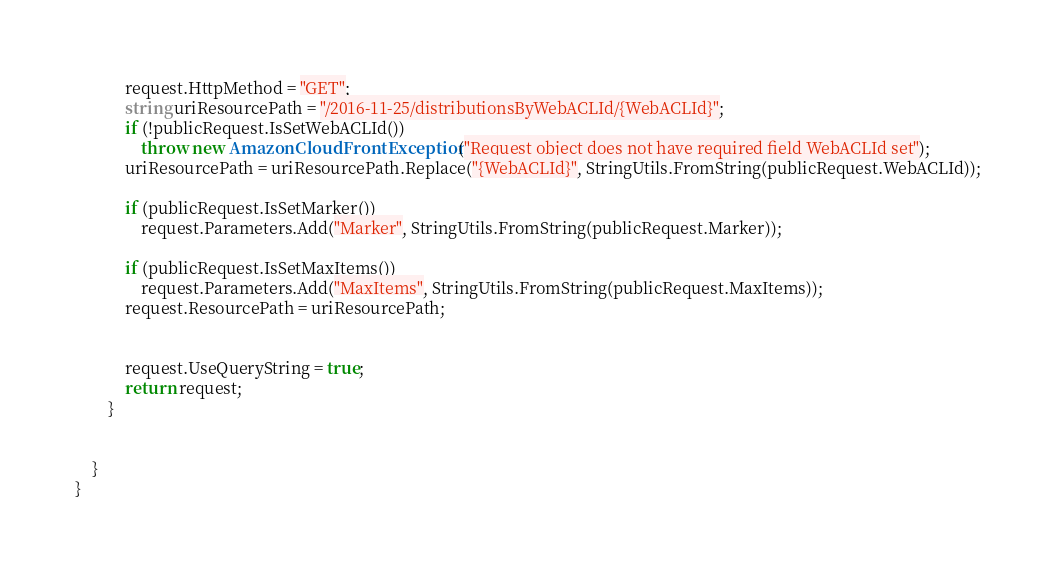<code> <loc_0><loc_0><loc_500><loc_500><_C#_>            request.HttpMethod = "GET";
            string uriResourcePath = "/2016-11-25/distributionsByWebACLId/{WebACLId}";
            if (!publicRequest.IsSetWebACLId())
                throw new AmazonCloudFrontException("Request object does not have required field WebACLId set");
            uriResourcePath = uriResourcePath.Replace("{WebACLId}", StringUtils.FromString(publicRequest.WebACLId));
            
            if (publicRequest.IsSetMarker())
                request.Parameters.Add("Marker", StringUtils.FromString(publicRequest.Marker));
            
            if (publicRequest.IsSetMaxItems())
                request.Parameters.Add("MaxItems", StringUtils.FromString(publicRequest.MaxItems));
            request.ResourcePath = uriResourcePath;


            request.UseQueryString = true;
            return request;
        }

        
    }    
}</code> 